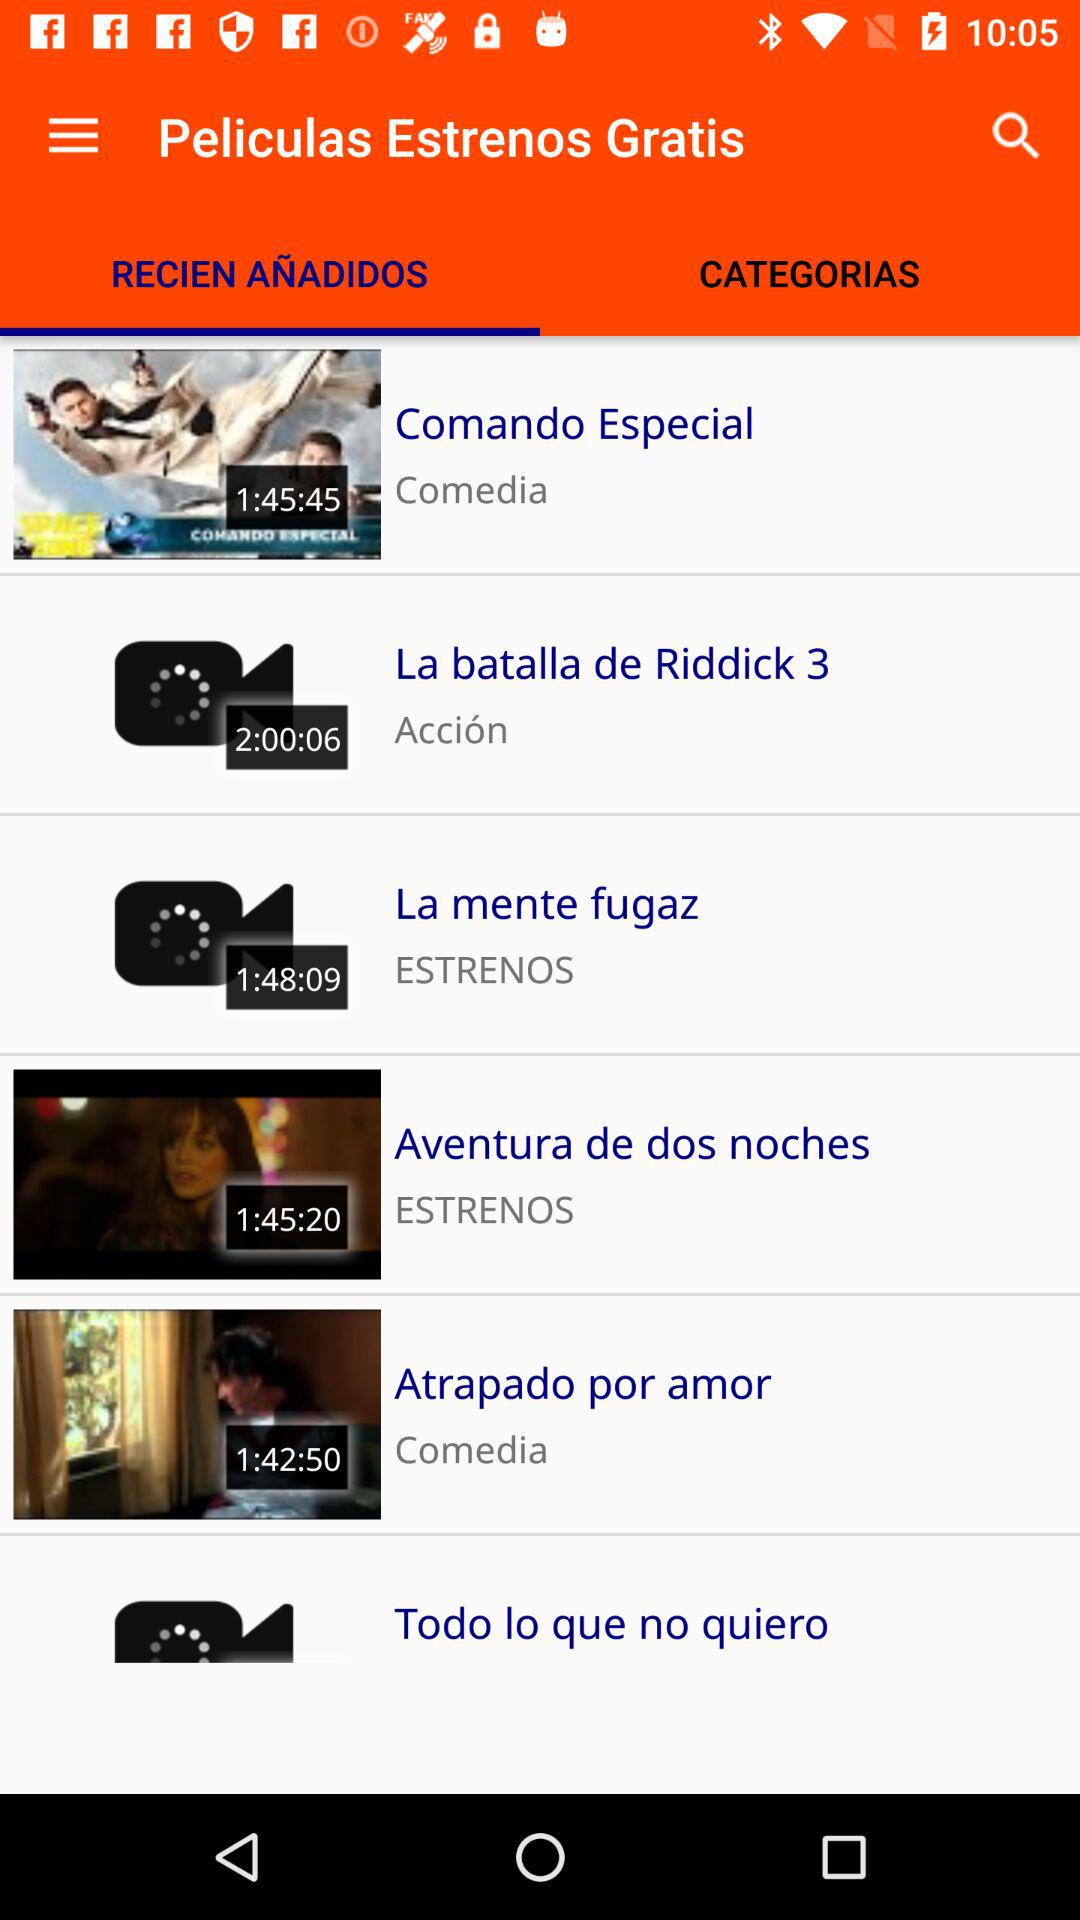How many of the movies are in the 'Acción' category?
Answer the question using a single word or phrase. 1 